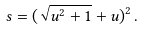Convert formula to latex. <formula><loc_0><loc_0><loc_500><loc_500>s = ( \sqrt { u ^ { 2 } + 1 } + u ) ^ { 2 } \, .</formula> 